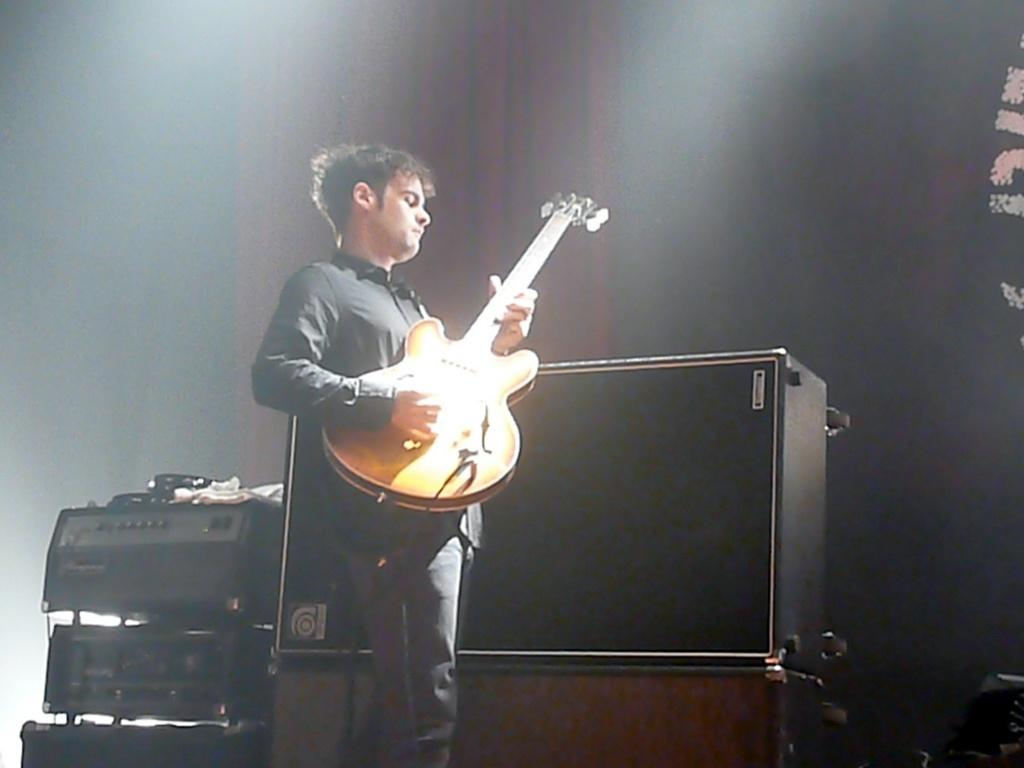What is the man in the image doing? The man is playing a guitar in the image. What else can be seen in the image besides the man? There are electronic devices in the image. What is the color of the electronic devices? The electronic devices are black in color. What type of brass instrument is the man playing in the image? The man is not playing a brass instrument in the image; he is playing a guitar. Can you see any teeth on the man in the image? There is no indication of the man's teeth in the image, as his mouth is not visible. 